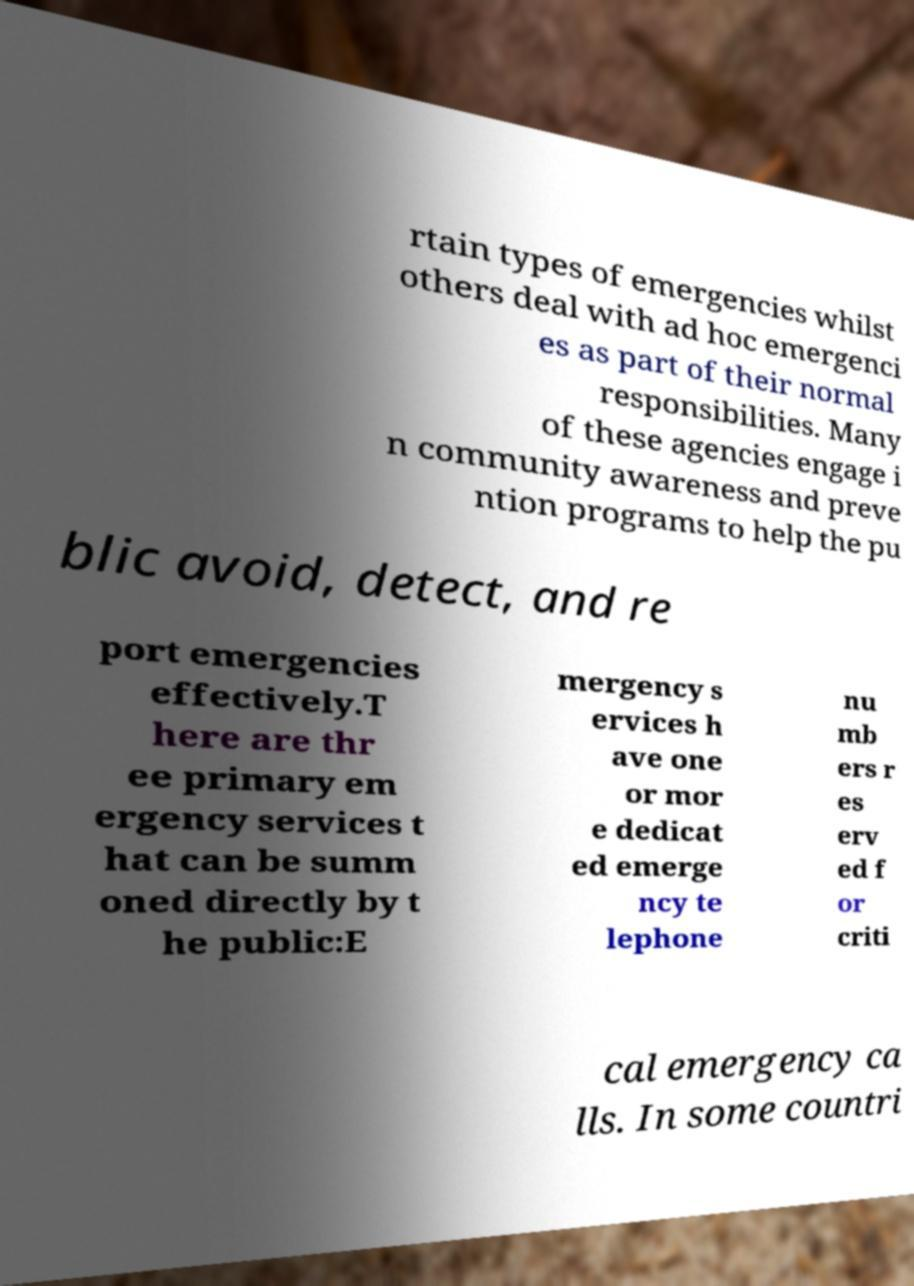What messages or text are displayed in this image? I need them in a readable, typed format. rtain types of emergencies whilst others deal with ad hoc emergenci es as part of their normal responsibilities. Many of these agencies engage i n community awareness and preve ntion programs to help the pu blic avoid, detect, and re port emergencies effectively.T here are thr ee primary em ergency services t hat can be summ oned directly by t he public:E mergency s ervices h ave one or mor e dedicat ed emerge ncy te lephone nu mb ers r es erv ed f or criti cal emergency ca lls. In some countri 